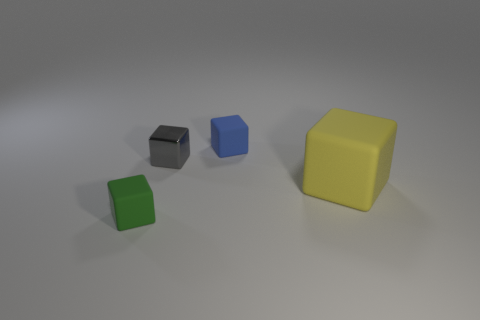Subtract all tiny gray shiny cubes. How many cubes are left? 3 Subtract all green blocks. How many blocks are left? 3 Add 3 big purple matte cylinders. How many objects exist? 7 Subtract 1 blocks. How many blocks are left? 3 Add 1 large yellow matte blocks. How many large yellow matte blocks exist? 2 Subtract 1 blue cubes. How many objects are left? 3 Subtract all brown blocks. Subtract all green balls. How many blocks are left? 4 Subtract all red cylinders. How many yellow blocks are left? 1 Subtract all purple matte cubes. Subtract all green cubes. How many objects are left? 3 Add 2 yellow cubes. How many yellow cubes are left? 3 